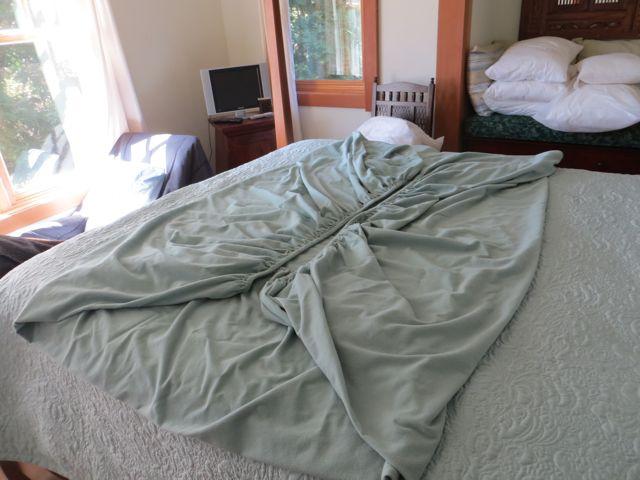What kind of sheet it's being folded?
Short answer required. Fitted. What is in the left corner?
Answer briefly. Window. Which room is this?
Give a very brief answer. Bedroom. 